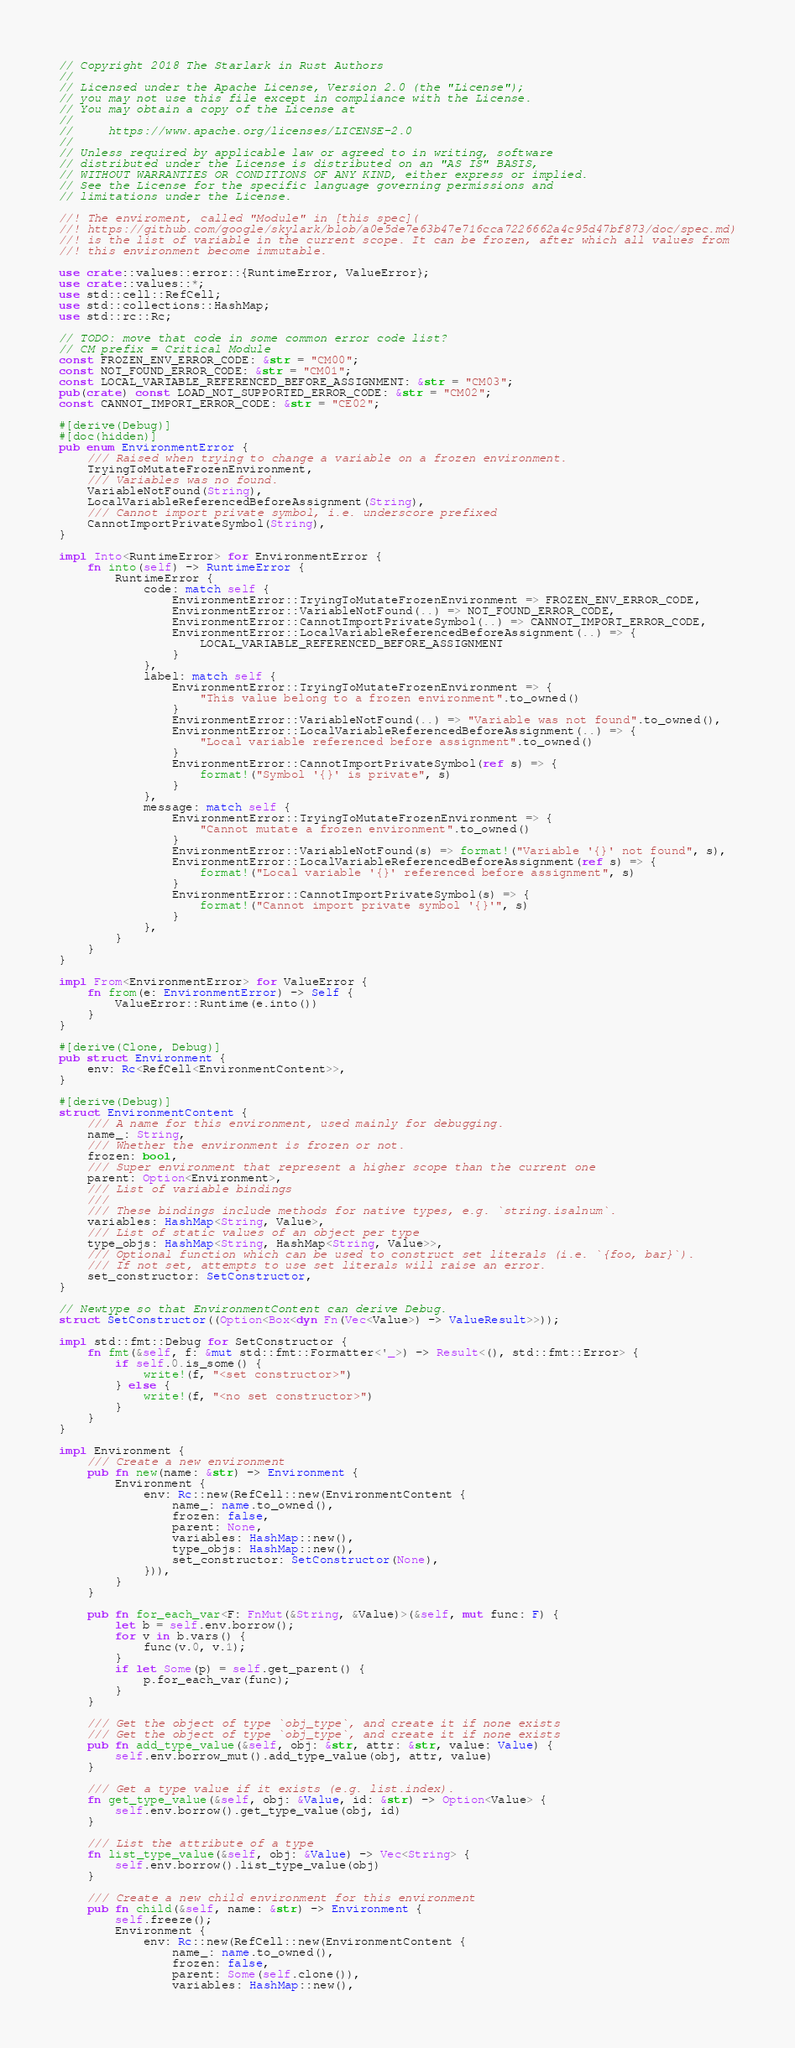<code> <loc_0><loc_0><loc_500><loc_500><_Rust_>// Copyright 2018 The Starlark in Rust Authors
//
// Licensed under the Apache License, Version 2.0 (the "License");
// you may not use this file except in compliance with the License.
// You may obtain a copy of the License at
//
//     https://www.apache.org/licenses/LICENSE-2.0
//
// Unless required by applicable law or agreed to in writing, software
// distributed under the License is distributed on an "AS IS" BASIS,
// WITHOUT WARRANTIES OR CONDITIONS OF ANY KIND, either express or implied.
// See the License for the specific language governing permissions and
// limitations under the License.

//! The enviroment, called "Module" in [this spec](
//! https://github.com/google/skylark/blob/a0e5de7e63b47e716cca7226662a4c95d47bf873/doc/spec.md)
//! is the list of variable in the current scope. It can be frozen, after which all values from
//! this environment become immutable.

use crate::values::error::{RuntimeError, ValueError};
use crate::values::*;
use std::cell::RefCell;
use std::collections::HashMap;
use std::rc::Rc;

// TODO: move that code in some common error code list?
// CM prefix = Critical Module
const FROZEN_ENV_ERROR_CODE: &str = "CM00";
const NOT_FOUND_ERROR_CODE: &str = "CM01";
const LOCAL_VARIABLE_REFERENCED_BEFORE_ASSIGNMENT: &str = "CM03";
pub(crate) const LOAD_NOT_SUPPORTED_ERROR_CODE: &str = "CM02";
const CANNOT_IMPORT_ERROR_CODE: &str = "CE02";

#[derive(Debug)]
#[doc(hidden)]
pub enum EnvironmentError {
    /// Raised when trying to change a variable on a frozen environment.
    TryingToMutateFrozenEnvironment,
    /// Variables was no found.
    VariableNotFound(String),
    LocalVariableReferencedBeforeAssignment(String),
    /// Cannot import private symbol, i.e. underscore prefixed
    CannotImportPrivateSymbol(String),
}

impl Into<RuntimeError> for EnvironmentError {
    fn into(self) -> RuntimeError {
        RuntimeError {
            code: match self {
                EnvironmentError::TryingToMutateFrozenEnvironment => FROZEN_ENV_ERROR_CODE,
                EnvironmentError::VariableNotFound(..) => NOT_FOUND_ERROR_CODE,
                EnvironmentError::CannotImportPrivateSymbol(..) => CANNOT_IMPORT_ERROR_CODE,
                EnvironmentError::LocalVariableReferencedBeforeAssignment(..) => {
                    LOCAL_VARIABLE_REFERENCED_BEFORE_ASSIGNMENT
                }
            },
            label: match self {
                EnvironmentError::TryingToMutateFrozenEnvironment => {
                    "This value belong to a frozen environment".to_owned()
                }
                EnvironmentError::VariableNotFound(..) => "Variable was not found".to_owned(),
                EnvironmentError::LocalVariableReferencedBeforeAssignment(..) => {
                    "Local variable referenced before assignment".to_owned()
                }
                EnvironmentError::CannotImportPrivateSymbol(ref s) => {
                    format!("Symbol '{}' is private", s)
                }
            },
            message: match self {
                EnvironmentError::TryingToMutateFrozenEnvironment => {
                    "Cannot mutate a frozen environment".to_owned()
                }
                EnvironmentError::VariableNotFound(s) => format!("Variable '{}' not found", s),
                EnvironmentError::LocalVariableReferencedBeforeAssignment(ref s) => {
                    format!("Local variable '{}' referenced before assignment", s)
                }
                EnvironmentError::CannotImportPrivateSymbol(s) => {
                    format!("Cannot import private symbol '{}'", s)
                }
            },
        }
    }
}

impl From<EnvironmentError> for ValueError {
    fn from(e: EnvironmentError) -> Self {
        ValueError::Runtime(e.into())
    }
}

#[derive(Clone, Debug)]
pub struct Environment {
    env: Rc<RefCell<EnvironmentContent>>,
}

#[derive(Debug)]
struct EnvironmentContent {
    /// A name for this environment, used mainly for debugging.
    name_: String,
    /// Whether the environment is frozen or not.
    frozen: bool,
    /// Super environment that represent a higher scope than the current one
    parent: Option<Environment>,
    /// List of variable bindings
    ///
    /// These bindings include methods for native types, e.g. `string.isalnum`.
    variables: HashMap<String, Value>,
    /// List of static values of an object per type
    type_objs: HashMap<String, HashMap<String, Value>>,
    /// Optional function which can be used to construct set literals (i.e. `{foo, bar}`).
    /// If not set, attempts to use set literals will raise an error.
    set_constructor: SetConstructor,
}

// Newtype so that EnvironmentContent can derive Debug.
struct SetConstructor((Option<Box<dyn Fn(Vec<Value>) -> ValueResult>>));

impl std::fmt::Debug for SetConstructor {
    fn fmt(&self, f: &mut std::fmt::Formatter<'_>) -> Result<(), std::fmt::Error> {
        if self.0.is_some() {
            write!(f, "<set constructor>")
        } else {
            write!(f, "<no set constructor>")
        }
    }
}

impl Environment {
    /// Create a new environment
    pub fn new(name: &str) -> Environment {
        Environment {
            env: Rc::new(RefCell::new(EnvironmentContent {
                name_: name.to_owned(),
                frozen: false,
                parent: None,
                variables: HashMap::new(),
                type_objs: HashMap::new(),
                set_constructor: SetConstructor(None),
            })),
        }
    }

    pub fn for_each_var<F: FnMut(&String, &Value)>(&self, mut func: F) {
        let b = self.env.borrow();
        for v in b.vars() {
            func(v.0, v.1);
        }
        if let Some(p) = self.get_parent() {
            p.for_each_var(func);
        }
    }

    /// Get the object of type `obj_type`, and create it if none exists
    /// Get the object of type `obj_type`, and create it if none exists
    pub fn add_type_value(&self, obj: &str, attr: &str, value: Value) {
        self.env.borrow_mut().add_type_value(obj, attr, value)
    }

    /// Get a type value if it exists (e.g. list.index).
    fn get_type_value(&self, obj: &Value, id: &str) -> Option<Value> {
        self.env.borrow().get_type_value(obj, id)
    }

    /// List the attribute of a type
    fn list_type_value(&self, obj: &Value) -> Vec<String> {
        self.env.borrow().list_type_value(obj)
    }

    /// Create a new child environment for this environment
    pub fn child(&self, name: &str) -> Environment {
        self.freeze();
        Environment {
            env: Rc::new(RefCell::new(EnvironmentContent {
                name_: name.to_owned(),
                frozen: false,
                parent: Some(self.clone()),
                variables: HashMap::new(),</code> 